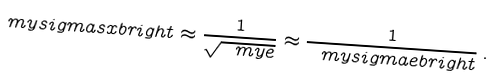Convert formula to latex. <formula><loc_0><loc_0><loc_500><loc_500>\ m y s i g m a s x b r i g h t \approx \frac { 1 } { \sqrt { \ m y e } } \approx \frac { 1 } { \ m y s i g m a e b r i g h t } \, .</formula> 